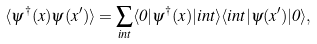Convert formula to latex. <formula><loc_0><loc_0><loc_500><loc_500>\langle \psi ^ { \dagger } ( x ) \psi ( x ^ { \prime } ) \rangle = \sum _ { i n t } \langle 0 | \psi ^ { \dagger } ( x ) | i n t \rangle \langle i n t | \psi ( x ^ { \prime } ) | 0 \rangle ,</formula> 